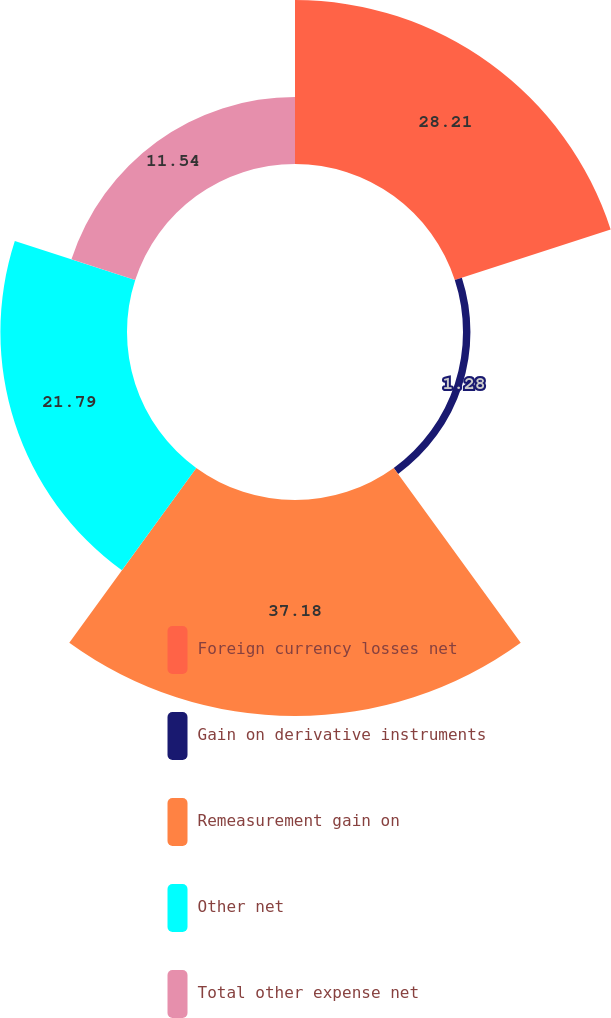Convert chart. <chart><loc_0><loc_0><loc_500><loc_500><pie_chart><fcel>Foreign currency losses net<fcel>Gain on derivative instruments<fcel>Remeasurement gain on<fcel>Other net<fcel>Total other expense net<nl><fcel>28.21%<fcel>1.28%<fcel>37.18%<fcel>21.79%<fcel>11.54%<nl></chart> 